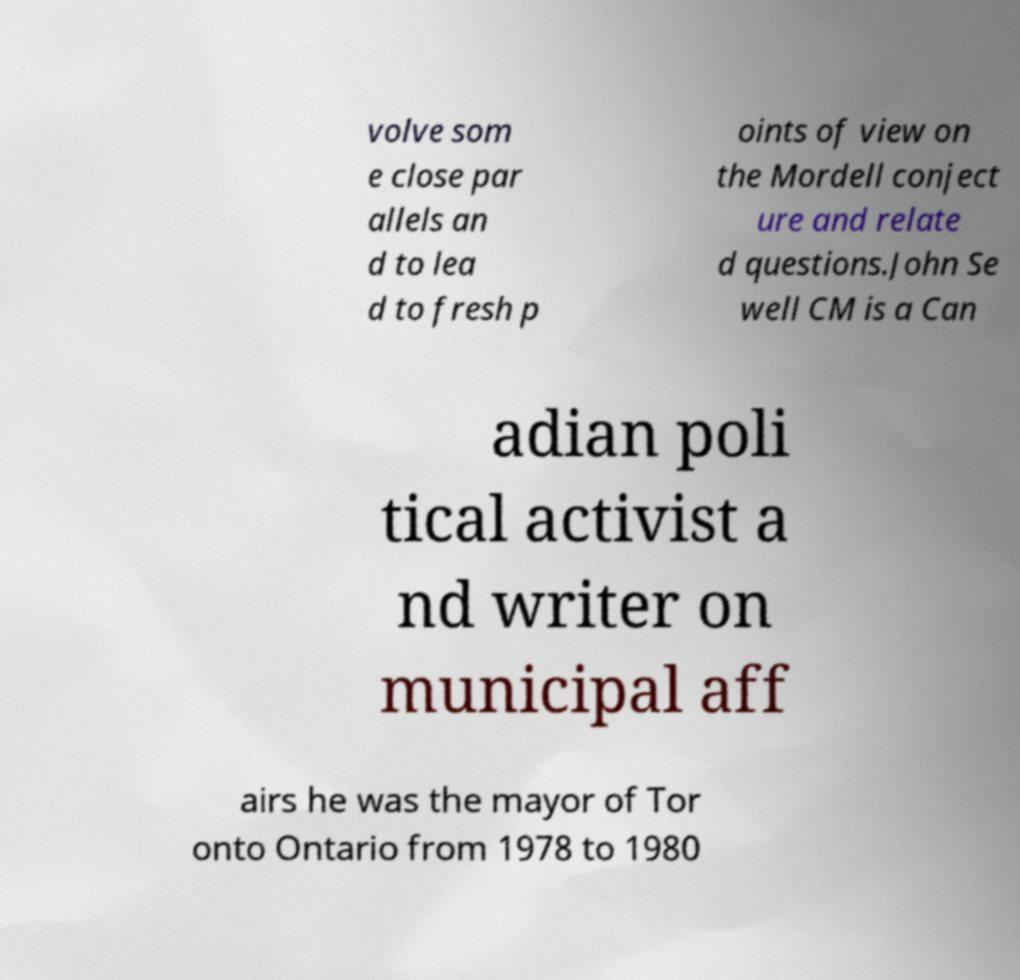Please read and relay the text visible in this image. What does it say? volve som e close par allels an d to lea d to fresh p oints of view on the Mordell conject ure and relate d questions.John Se well CM is a Can adian poli tical activist a nd writer on municipal aff airs he was the mayor of Tor onto Ontario from 1978 to 1980 